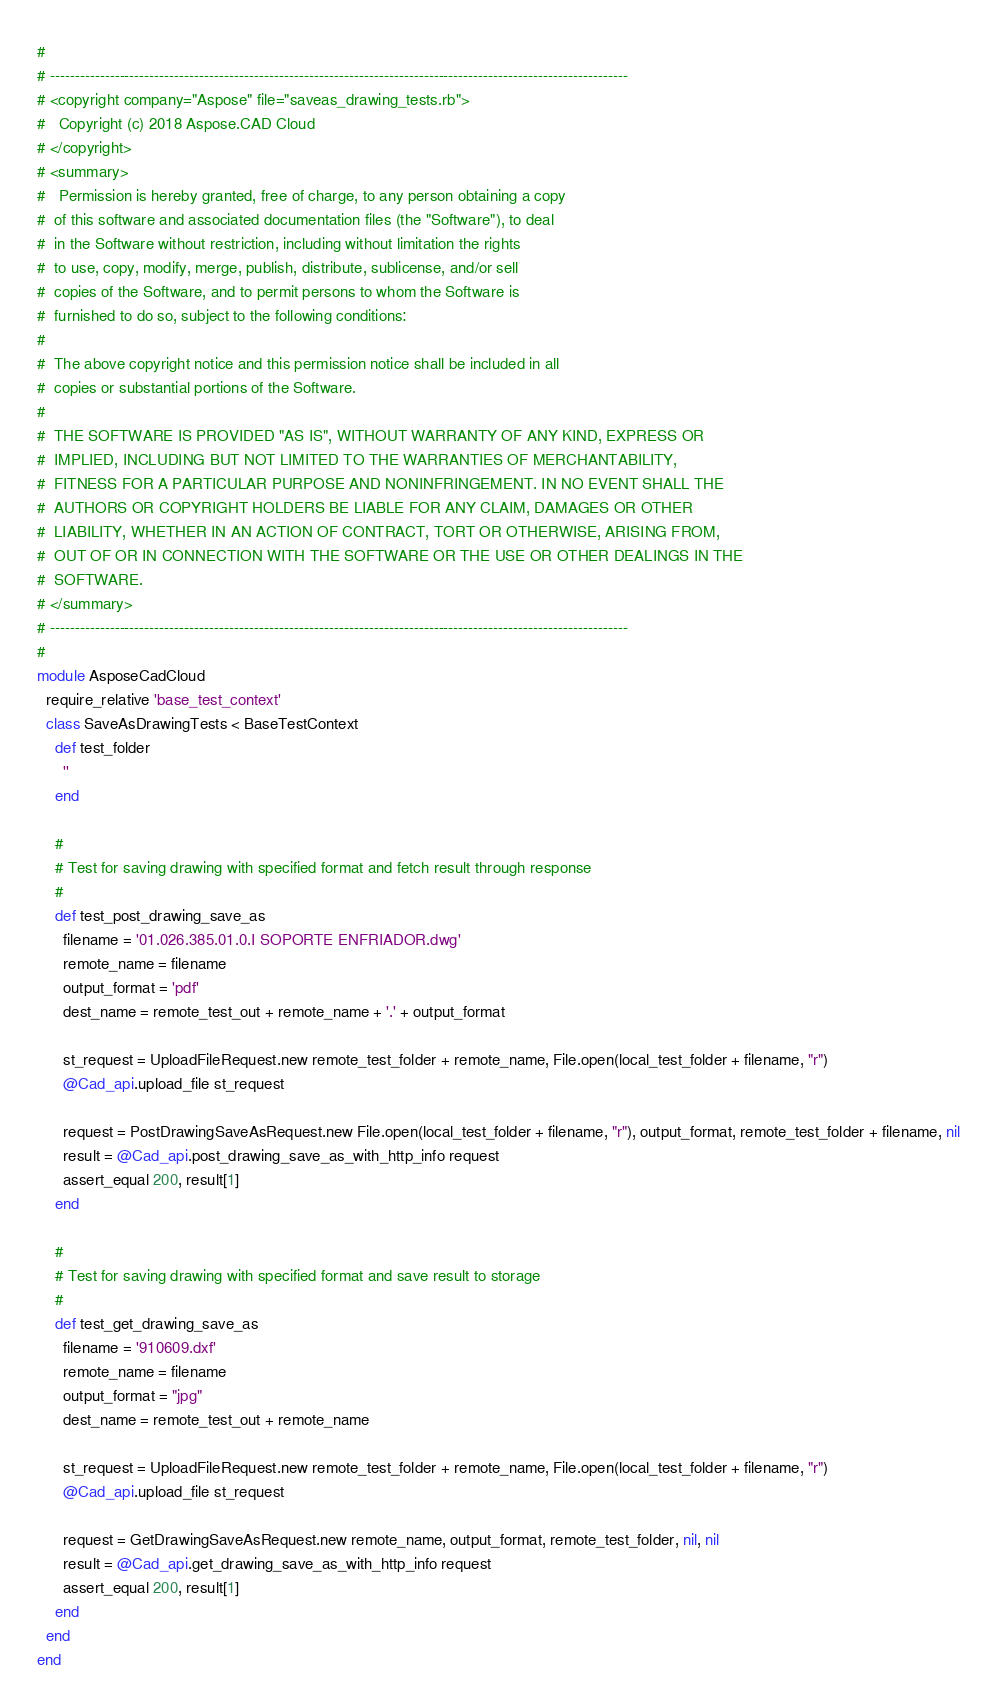<code> <loc_0><loc_0><loc_500><loc_500><_Ruby_>#
# --------------------------------------------------------------------------------------------------------------------
# <copyright company="Aspose" file="saveas_drawing_tests.rb">
#   Copyright (c) 2018 Aspose.CAD Cloud
# </copyright>
# <summary>
#   Permission is hereby granted, free of charge, to any person obtaining a copy
#  of this software and associated documentation files (the "Software"), to deal
#  in the Software without restriction, including without limitation the rights
#  to use, copy, modify, merge, publish, distribute, sublicense, and/or sell
#  copies of the Software, and to permit persons to whom the Software is
#  furnished to do so, subject to the following conditions:
#
#  The above copyright notice and this permission notice shall be included in all
#  copies or substantial portions of the Software.
#
#  THE SOFTWARE IS PROVIDED "AS IS", WITHOUT WARRANTY OF ANY KIND, EXPRESS OR
#  IMPLIED, INCLUDING BUT NOT LIMITED TO THE WARRANTIES OF MERCHANTABILITY,
#  FITNESS FOR A PARTICULAR PURPOSE AND NONINFRINGEMENT. IN NO EVENT SHALL THE
#  AUTHORS OR COPYRIGHT HOLDERS BE LIABLE FOR ANY CLAIM, DAMAGES OR OTHER
#  LIABILITY, WHETHER IN AN ACTION OF CONTRACT, TORT OR OTHERWISE, ARISING FROM,
#  OUT OF OR IN CONNECTION WITH THE SOFTWARE OR THE USE OR OTHER DEALINGS IN THE
#  SOFTWARE.
# </summary>
# --------------------------------------------------------------------------------------------------------------------
#
module AsposeCadCloud
  require_relative 'base_test_context'
  class SaveAsDrawingTests < BaseTestContext
    def test_folder
      ''
    end

    #
    # Test for saving drawing with specified format and fetch result through response
    #
    def test_post_drawing_save_as
      filename = '01.026.385.01.0.I SOPORTE ENFRIADOR.dwg'
      remote_name = filename
      output_format = 'pdf'
      dest_name = remote_test_out + remote_name + '.' + output_format

      st_request = UploadFileRequest.new remote_test_folder + remote_name, File.open(local_test_folder + filename, "r")
      @Cad_api.upload_file st_request

      request = PostDrawingSaveAsRequest.new File.open(local_test_folder + filename, "r"), output_format, remote_test_folder + filename, nil
      result = @Cad_api.post_drawing_save_as_with_http_info request
      assert_equal 200, result[1]
    end

    #
    # Test for saving drawing with specified format and save result to storage
    #
    def test_get_drawing_save_as
      filename = '910609.dxf'
      remote_name = filename
      output_format = "jpg"
      dest_name = remote_test_out + remote_name

      st_request = UploadFileRequest.new remote_test_folder + remote_name, File.open(local_test_folder + filename, "r")
      @Cad_api.upload_file st_request

      request = GetDrawingSaveAsRequest.new remote_name, output_format, remote_test_folder, nil, nil
      result = @Cad_api.get_drawing_save_as_with_http_info request
      assert_equal 200, result[1]
    end
  end
end</code> 